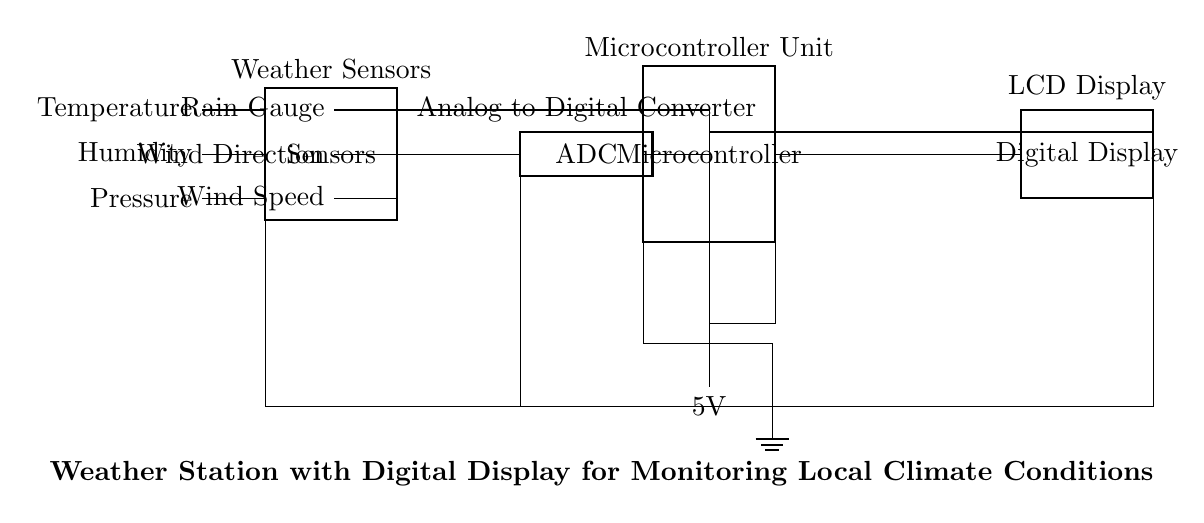What components are used in this weather station? The circuit diagram shows several components: Temperature sensor, Humidity sensor, Pressure sensor, Wind Speed sensor, Wind Direction sensor, Rain Gauge, Analog-to-Digital Converter, Microcontroller Unit, and Digital Display.
Answer: Sensors, ADC, MCU, Display What type of power supply is used in this circuit? The diagram illustrates a battery with a label indicating a voltage of 5V, indicating a direct current power supply for the circuit.
Answer: 5V battery How many pins does the Microcontroller Unit have in this design? The Microcontroller unit is depicted as a dip chip with 8 pins as shown in the diagram.
Answer: 8 pins Which component connects the sensors to the microcontroller? The connection between the sensors and the microcontroller is facilitated by the Analog-to-Digital Converter, as depicted in the circuit diagram.
Answer: ADC What is the purpose of the Analog-to-Digital Converter in this circuit? The ADC converts the analog signals from the various weather sensors into digital signals, which the microcontroller can process and display, illustrating its essential function in a digital weather station.
Answer: Converts analog to digital How is the power supplied to the Digital Display? The Digital Display receives power through a connection from the battery, which also powers the Microcontroller and other components in the circuit, demonstrating the shared power arrangement.
Answer: From the battery What is the main function of this entire circuit? The overall function of the circuit is to monitor local climate conditions by measuring various environmental parameters and displaying them digitally, revealing its intended purpose as a weather station.
Answer: Monitor climate conditions 